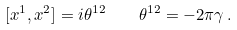<formula> <loc_0><loc_0><loc_500><loc_500>[ x ^ { 1 } , x ^ { 2 } ] = i \theta ^ { 1 2 } \, \quad \theta ^ { 1 2 } = - 2 \pi \gamma \, .</formula> 